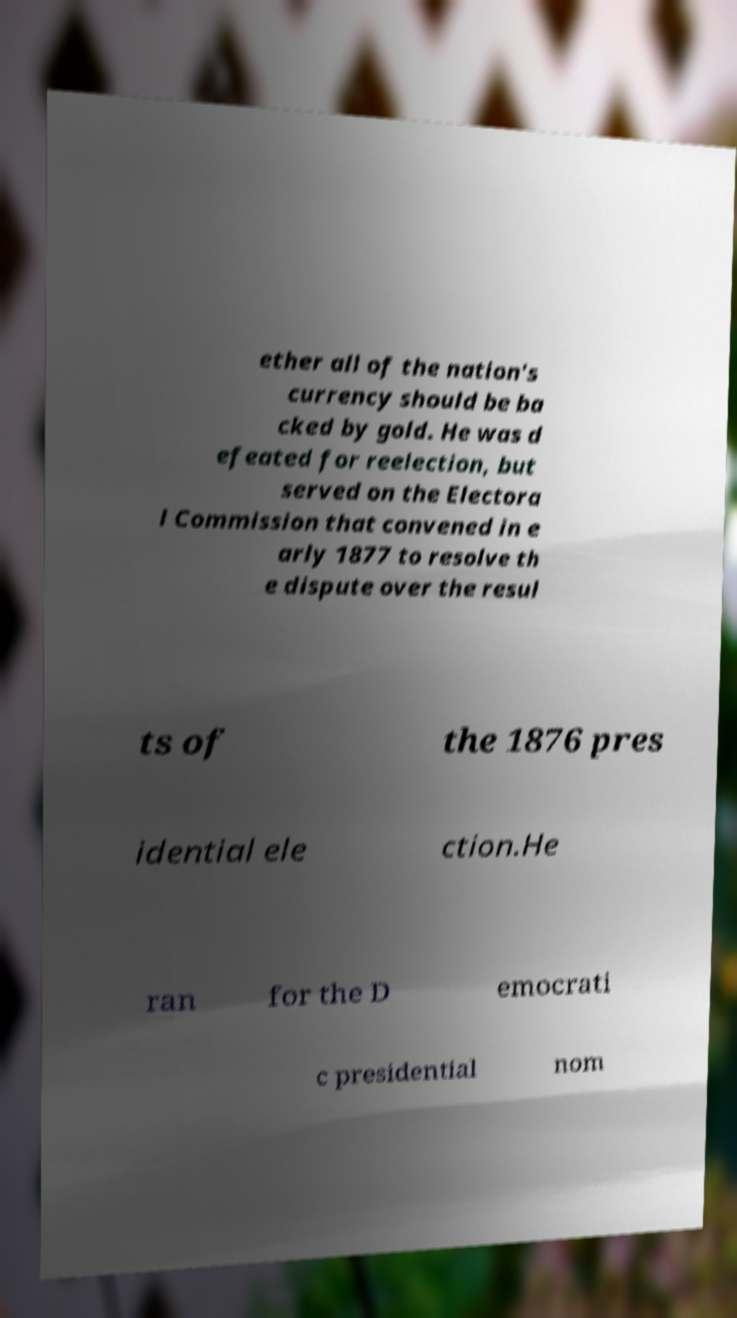Please read and relay the text visible in this image. What does it say? ether all of the nation's currency should be ba cked by gold. He was d efeated for reelection, but served on the Electora l Commission that convened in e arly 1877 to resolve th e dispute over the resul ts of the 1876 pres idential ele ction.He ran for the D emocrati c presidential nom 